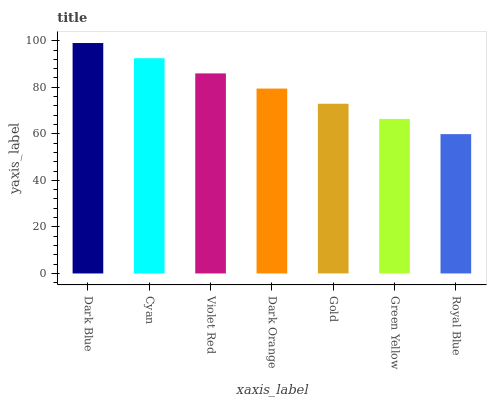Is Dark Blue the maximum?
Answer yes or no. Yes. Is Cyan the minimum?
Answer yes or no. No. Is Cyan the maximum?
Answer yes or no. No. Is Dark Blue greater than Cyan?
Answer yes or no. Yes. Is Cyan less than Dark Blue?
Answer yes or no. Yes. Is Cyan greater than Dark Blue?
Answer yes or no. No. Is Dark Blue less than Cyan?
Answer yes or no. No. Is Dark Orange the high median?
Answer yes or no. Yes. Is Dark Orange the low median?
Answer yes or no. Yes. Is Green Yellow the high median?
Answer yes or no. No. Is Violet Red the low median?
Answer yes or no. No. 